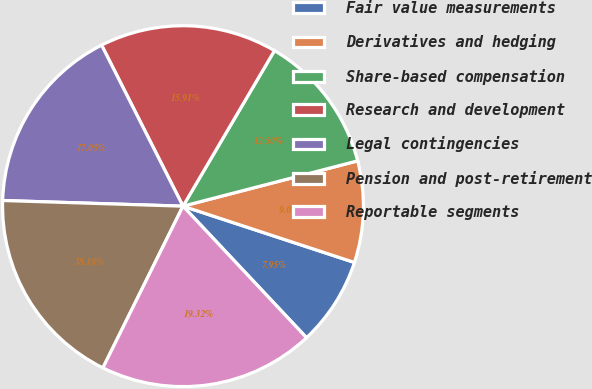Convert chart to OTSL. <chart><loc_0><loc_0><loc_500><loc_500><pie_chart><fcel>Fair value measurements<fcel>Derivatives and hedging<fcel>Share-based compensation<fcel>Research and development<fcel>Legal contingencies<fcel>Pension and post-retirement<fcel>Reportable segments<nl><fcel>7.95%<fcel>9.09%<fcel>12.5%<fcel>15.91%<fcel>17.05%<fcel>18.18%<fcel>19.32%<nl></chart> 